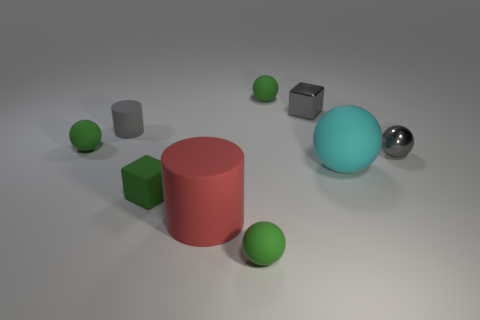What number of objects are large red cylinders or big cyan spheres?
Provide a short and direct response. 2. There is a tiny gray rubber thing behind the cyan matte ball; are there any green rubber things on the left side of it?
Your answer should be very brief. Yes. Are there more balls that are behind the gray rubber cylinder than cylinders that are to the right of the big cyan rubber object?
Ensure brevity in your answer.  Yes. There is a cube that is the same color as the metallic sphere; what is its material?
Your answer should be compact. Metal. What number of small rubber objects are the same color as the large rubber sphere?
Your response must be concise. 0. There is a small block that is to the left of the gray cube; does it have the same color as the small sphere in front of the small shiny sphere?
Give a very brief answer. Yes. There is a green rubber cube; are there any cyan matte spheres behind it?
Offer a terse response. Yes. What is the material of the tiny gray cylinder?
Offer a very short reply. Rubber. What is the shape of the small gray thing that is behind the tiny cylinder?
Provide a short and direct response. Cube. What size is the cube that is the same color as the small metal sphere?
Ensure brevity in your answer.  Small. 